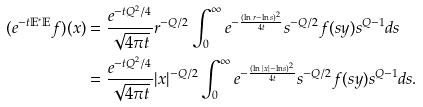<formula> <loc_0><loc_0><loc_500><loc_500>( e ^ { - t \mathbb { E } ^ { * } \mathbb { E } } f ) ( x ) & = \frac { e ^ { - t Q ^ { 2 } / 4 } } { \sqrt { 4 \pi t } } r ^ { - Q / 2 } \int ^ { \infty } _ { 0 } e ^ { - \frac { ( \ln r - \ln s ) ^ { 2 } } { 4 t } } s ^ { - Q / 2 } f ( s y ) s ^ { Q - 1 } d s \\ & = \frac { e ^ { - t Q ^ { 2 } / 4 } } { \sqrt { 4 \pi t } } | x | ^ { - Q / 2 } \int ^ { \infty } _ { 0 } e ^ { - \frac { ( \ln | x | - \ln s ) ^ { 2 } } { 4 t } } s ^ { - Q / 2 } f ( s y ) s ^ { Q - 1 } d s .</formula> 